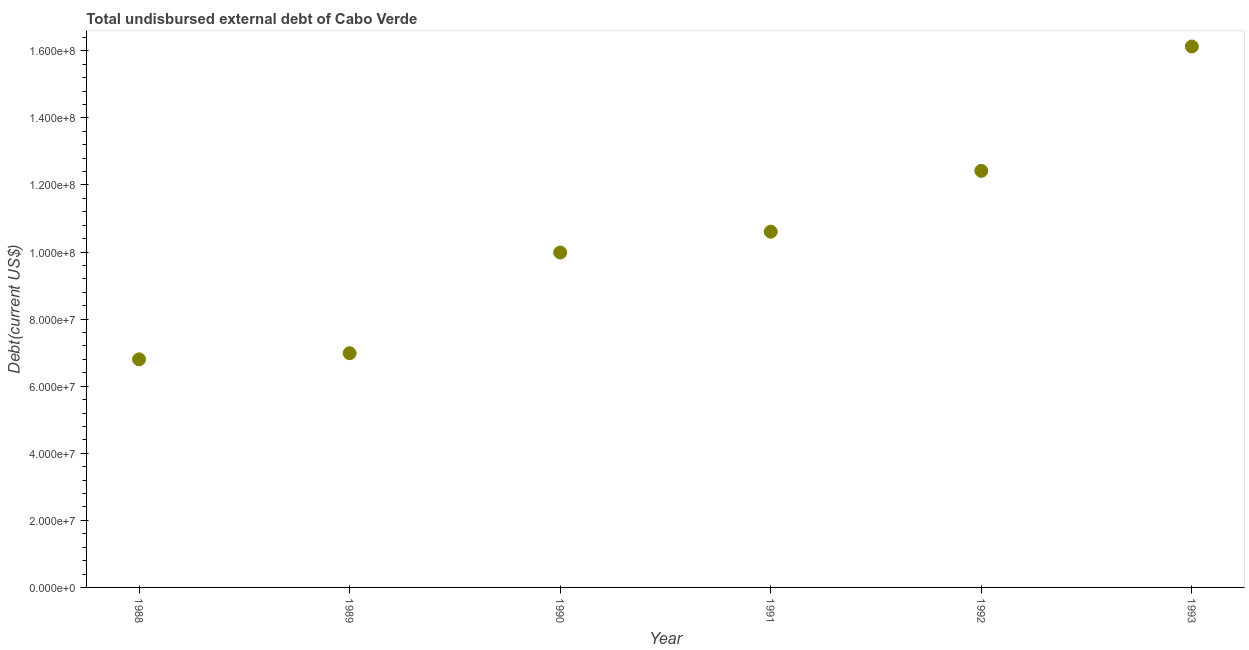What is the total debt in 1989?
Give a very brief answer. 6.98e+07. Across all years, what is the maximum total debt?
Provide a succinct answer. 1.61e+08. Across all years, what is the minimum total debt?
Offer a terse response. 6.80e+07. In which year was the total debt maximum?
Your answer should be very brief. 1993. What is the sum of the total debt?
Ensure brevity in your answer.  6.29e+08. What is the difference between the total debt in 1991 and 1993?
Offer a terse response. -5.52e+07. What is the average total debt per year?
Your response must be concise. 1.05e+08. What is the median total debt?
Offer a terse response. 1.03e+08. In how many years, is the total debt greater than 32000000 US$?
Offer a very short reply. 6. Do a majority of the years between 1991 and 1988 (inclusive) have total debt greater than 76000000 US$?
Provide a succinct answer. Yes. What is the ratio of the total debt in 1989 to that in 1992?
Give a very brief answer. 0.56. Is the total debt in 1989 less than that in 1992?
Make the answer very short. Yes. What is the difference between the highest and the second highest total debt?
Offer a very short reply. 3.71e+07. What is the difference between the highest and the lowest total debt?
Your response must be concise. 9.33e+07. How many years are there in the graph?
Your response must be concise. 6. Are the values on the major ticks of Y-axis written in scientific E-notation?
Ensure brevity in your answer.  Yes. What is the title of the graph?
Provide a short and direct response. Total undisbursed external debt of Cabo Verde. What is the label or title of the Y-axis?
Offer a terse response. Debt(current US$). What is the Debt(current US$) in 1988?
Provide a short and direct response. 6.80e+07. What is the Debt(current US$) in 1989?
Give a very brief answer. 6.98e+07. What is the Debt(current US$) in 1990?
Keep it short and to the point. 9.99e+07. What is the Debt(current US$) in 1991?
Keep it short and to the point. 1.06e+08. What is the Debt(current US$) in 1992?
Give a very brief answer. 1.24e+08. What is the Debt(current US$) in 1993?
Give a very brief answer. 1.61e+08. What is the difference between the Debt(current US$) in 1988 and 1989?
Your answer should be very brief. -1.83e+06. What is the difference between the Debt(current US$) in 1988 and 1990?
Give a very brief answer. -3.19e+07. What is the difference between the Debt(current US$) in 1988 and 1991?
Your response must be concise. -3.81e+07. What is the difference between the Debt(current US$) in 1988 and 1992?
Ensure brevity in your answer.  -5.62e+07. What is the difference between the Debt(current US$) in 1988 and 1993?
Give a very brief answer. -9.33e+07. What is the difference between the Debt(current US$) in 1989 and 1990?
Offer a very short reply. -3.00e+07. What is the difference between the Debt(current US$) in 1989 and 1991?
Provide a succinct answer. -3.62e+07. What is the difference between the Debt(current US$) in 1989 and 1992?
Ensure brevity in your answer.  -5.44e+07. What is the difference between the Debt(current US$) in 1989 and 1993?
Your response must be concise. -9.15e+07. What is the difference between the Debt(current US$) in 1990 and 1991?
Your answer should be very brief. -6.20e+06. What is the difference between the Debt(current US$) in 1990 and 1992?
Your answer should be very brief. -2.43e+07. What is the difference between the Debt(current US$) in 1990 and 1993?
Provide a short and direct response. -6.14e+07. What is the difference between the Debt(current US$) in 1991 and 1992?
Offer a very short reply. -1.81e+07. What is the difference between the Debt(current US$) in 1991 and 1993?
Offer a very short reply. -5.52e+07. What is the difference between the Debt(current US$) in 1992 and 1993?
Make the answer very short. -3.71e+07. What is the ratio of the Debt(current US$) in 1988 to that in 1990?
Make the answer very short. 0.68. What is the ratio of the Debt(current US$) in 1988 to that in 1991?
Offer a very short reply. 0.64. What is the ratio of the Debt(current US$) in 1988 to that in 1992?
Make the answer very short. 0.55. What is the ratio of the Debt(current US$) in 1988 to that in 1993?
Your answer should be compact. 0.42. What is the ratio of the Debt(current US$) in 1989 to that in 1990?
Keep it short and to the point. 0.7. What is the ratio of the Debt(current US$) in 1989 to that in 1991?
Your answer should be compact. 0.66. What is the ratio of the Debt(current US$) in 1989 to that in 1992?
Your answer should be compact. 0.56. What is the ratio of the Debt(current US$) in 1989 to that in 1993?
Offer a terse response. 0.43. What is the ratio of the Debt(current US$) in 1990 to that in 1991?
Ensure brevity in your answer.  0.94. What is the ratio of the Debt(current US$) in 1990 to that in 1992?
Offer a very short reply. 0.8. What is the ratio of the Debt(current US$) in 1990 to that in 1993?
Keep it short and to the point. 0.62. What is the ratio of the Debt(current US$) in 1991 to that in 1992?
Keep it short and to the point. 0.85. What is the ratio of the Debt(current US$) in 1991 to that in 1993?
Offer a very short reply. 0.66. What is the ratio of the Debt(current US$) in 1992 to that in 1993?
Your answer should be compact. 0.77. 